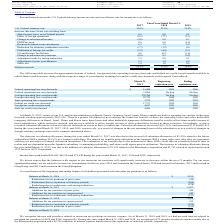According to Avx Corporation's financial document, What is the income tax paid in the year ended March 31, 2017? According to the financial document, $55,642. The relevant text states: "Income taxes paid totaled $55,642, $66,354 and $75,640 during the years ended March 31, 2017, 2018 and 2019, respectively. We do not..." Also, What is the income tax paid in the year ended March 31, 2018? According to the financial document, $66,354. The relevant text states: "Income taxes paid totaled $55,642, $66,354 and $75,640 during the years ended March 31, 2017, 2018 and 2019, respectively. We do not expect tha..." Also, What is the income tax paid in the year ended March 31, 2019? According to the financial document, $75,640. The relevant text states: "Income taxes paid totaled $55,642, $66,354 and $75,640 during the years ended March 31, 2017, 2018 and 2019, respectively. We do not expect that the balanc..." Also, can you calculate: What is the total income tax paid between 2017 to 2019? Based on the calculation: $55,642 + $66,354 + $75,640 , the result is 197636. This is based on the information: "Income taxes paid totaled $55,642, $66,354 and $75,640 during the years ended March 31, 2017, 2018 and 2019, respectively. We do not expect that the balan Income taxes paid totaled $55,642, $66,354 an..." The key data points involved are: 55,642, 66,354, 75,640. Also, can you calculate: How many years is the state tax credit carryforward? Based on the calculation: 2029 - 2020 , the result is 9. This is based on the information: "State tax credit carryforward 8,086 2020 2029 State tax credit carryforward 8,086 2020 2029..." The key data points involved are: 2020, 2029. Also, can you calculate: What is the total value of foreign and federal operating loss carryforwards with no expiry? Based on the calculation: 11,895 + 178,784 , the result is 190679. This is based on the information: "Foreign operating loss carryforwards 178,784 No Exp No Exp Federal operating loss carryforwards 11,895 No Exp No Exp..." The key data points involved are: 11,895, 178,784. 